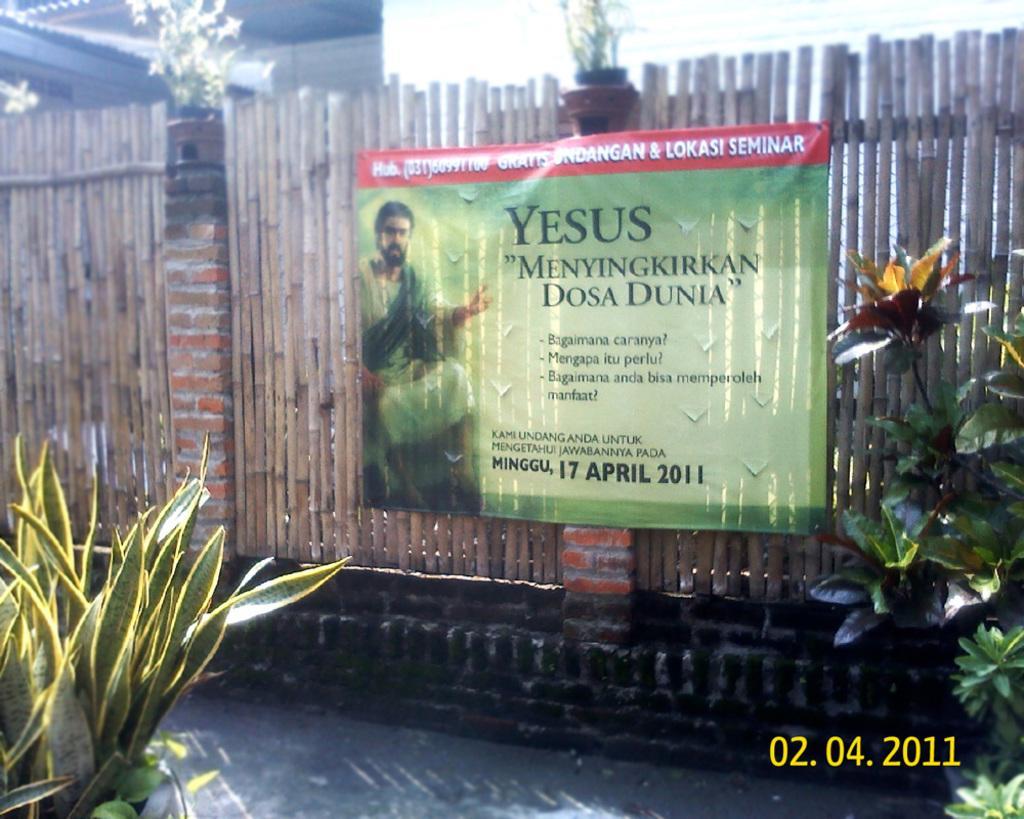Please provide a concise description of this image. This image is taken outdoors. At the bottom of the image there is a ground. On the left and right side of the image there are two plants. In the middle of the image there is a fencing with bricks and wooden sticks. There is a poster with a text on it. 